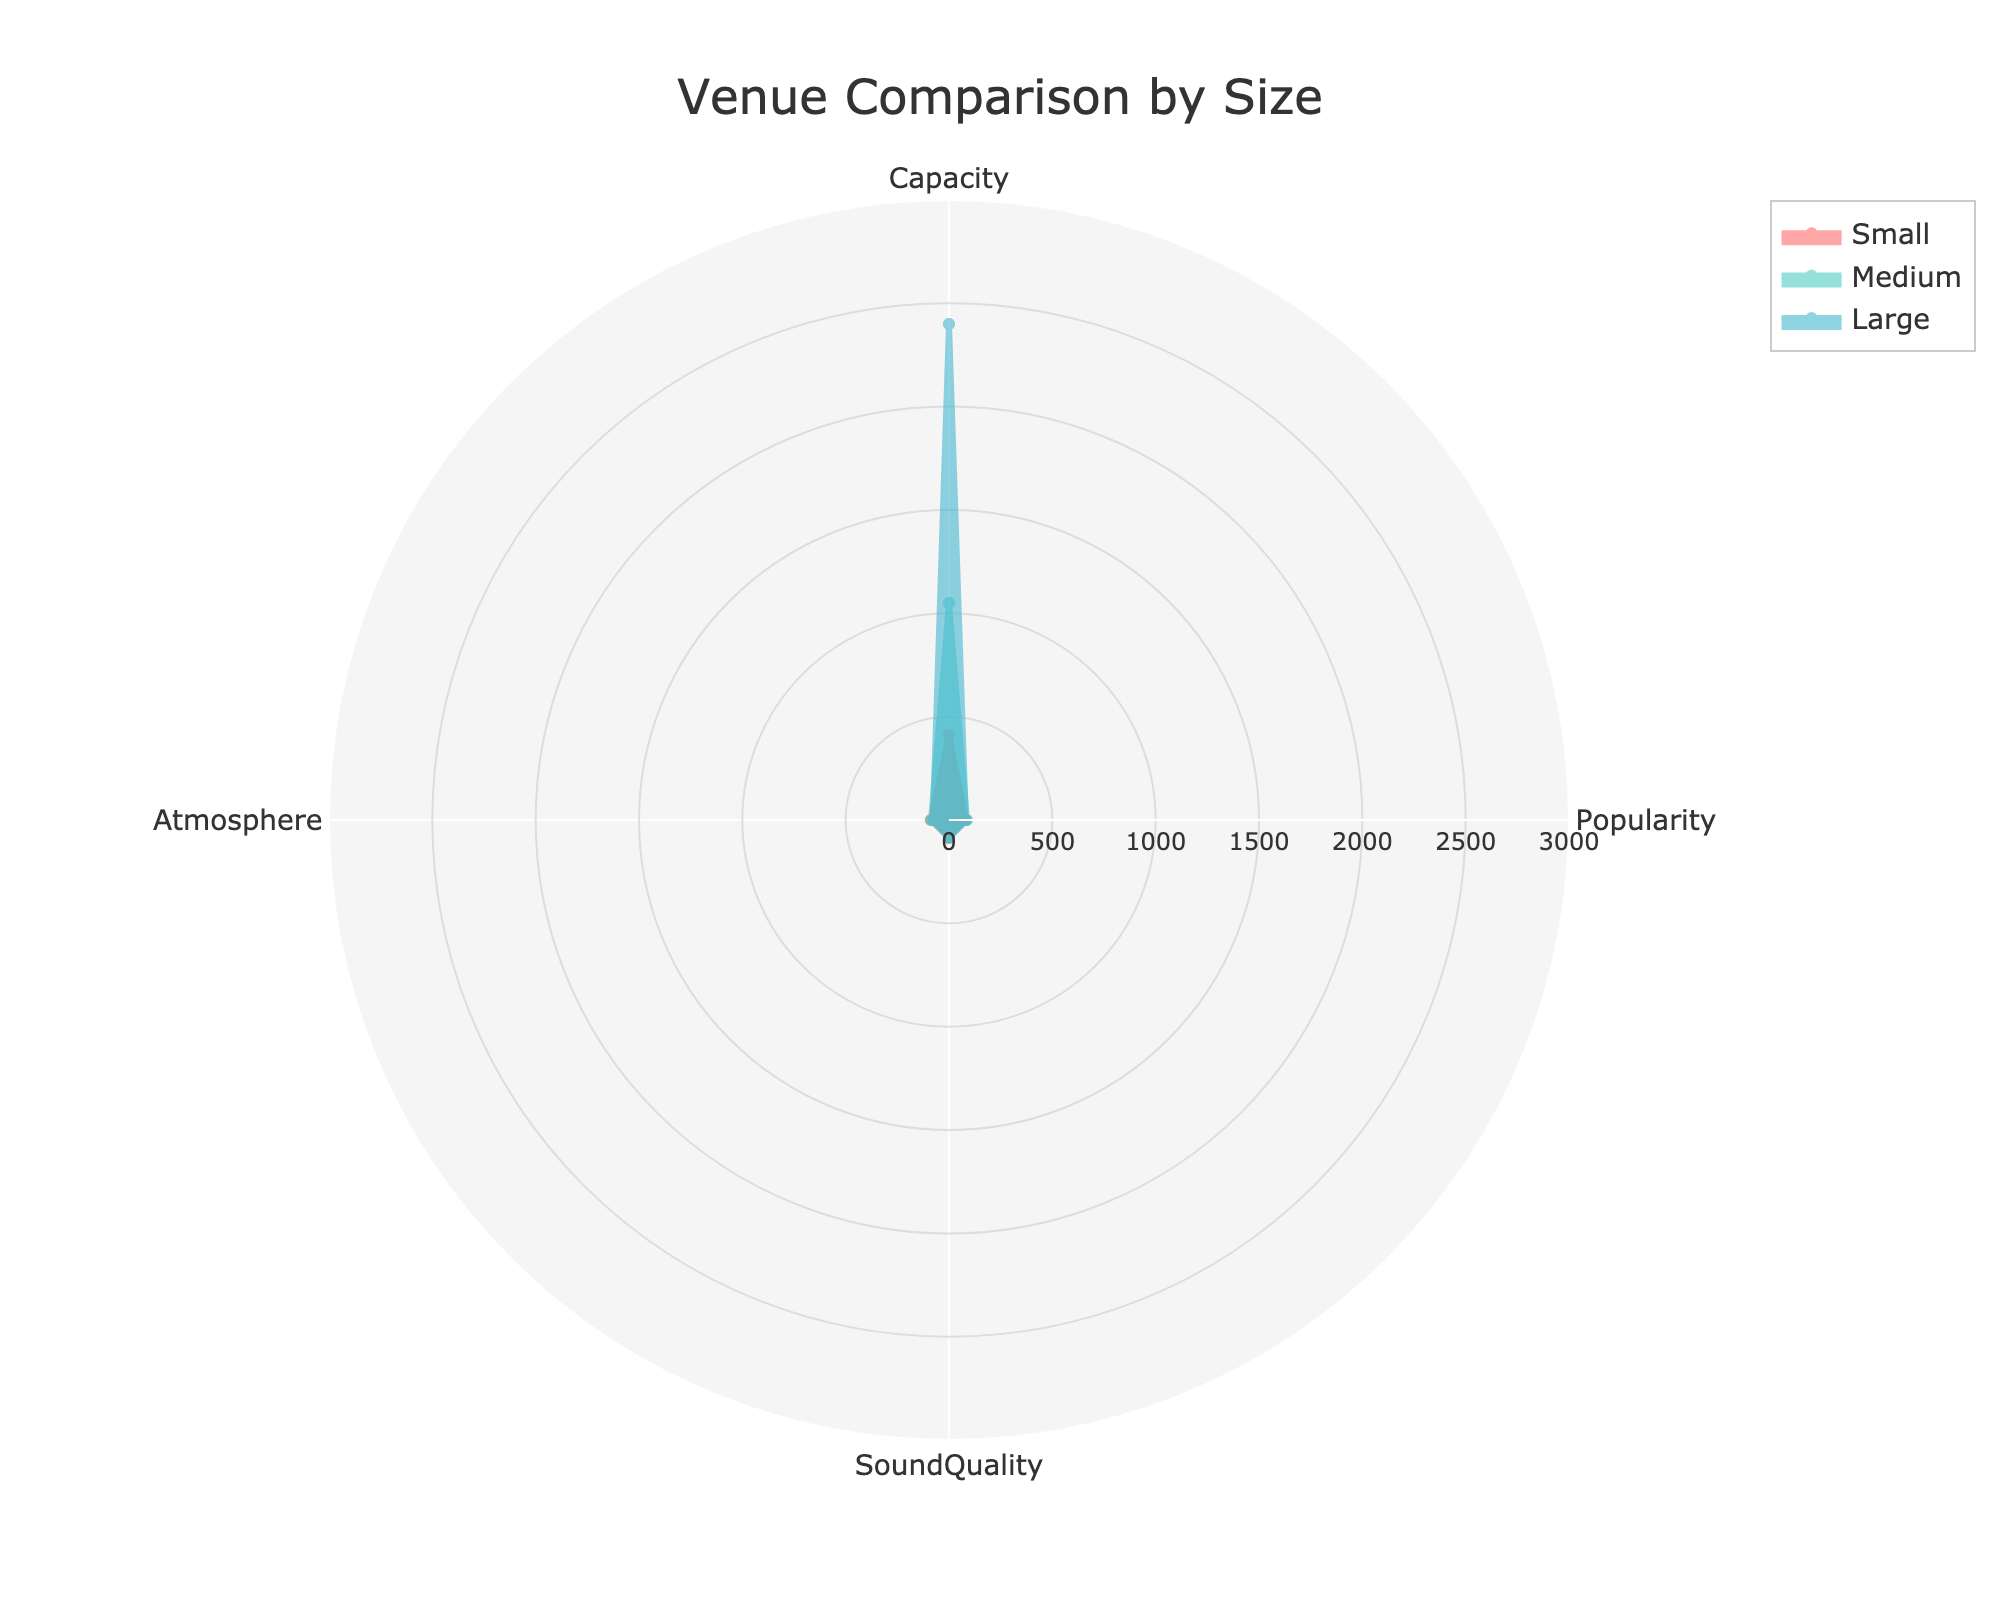How many categories are compared on the radar chart? The radar chart shows measurements across 4 distinct categories, which are used to compare the different venue sizes. These categories are noted at each axis of the chart.
Answer: 4 Which venue size has the highest average value for SoundQuality? To determine this, you locate the SoundQuality axis and observe where each size group (small, medium, large) extends. You see that the Medium size venues have the highest average value on the SoundQuality axis.
Answer: Medium How does the popularity of Large venues compare to Small venues? By examining the Popularity axis, you notice that the line and area representing Large venues are lower than that for Small venues. This indicates that the average popularity of Large venues is less than that of Small venues.
Answer: Large venues are less popular than Small venues What is the average capacity of Medium-sized venues displayed on the radar chart? The radar chart's capacity axis shows Medium venues, which include Music Hall of Williamsburg (650), Irving Plaza (1000), and Webster Hall (1500). The average capacity is calculated by adding these values and dividing by the number of venues: (650 + 1000 + 1500) / 3 = 3500 / 3.
Answer: 1167 Between Small and Medium venue sizes, which one has better Atmosphere ratings? By looking at the Atmosphere axis, you find that the line and area for the Medium venues extend further than that for Small venues. Thus, the Medium venues have better Atmosphere ratings.
Answer: Medium Which venue size category has the widest range in its Capacity values? To find the range, you look at the minimum and maximum values on the Capacity axis for each category. Medium venues have capacities ranging from 650 to 1500, while Large venues range from 1800 to 3000, and Small venues go from 250 to 575. Subtracting the smallest from the largest value gives you the ranges: 
Medium (1500 - 650 = 850), 
Large (3000 - 1800 = 1200), 
Small (575 - 250 = 325). 
Therefore, Large venues have the widest range.
Answer: Large Basically, what color represents Medium-sized venues? The color associated with each venue size is visibly distinct on the chart. The Medium-sized venues are represented in a greenish-blue hue.
Answer: Greenish-blue What's the difference in average Atmosphere ratings between Small and Large venue sizes? The radar chart shows the average Atmosphere ratings for Small and Large venue sizes. You find the Atmosphere axis for both, noting that Small venues have ratings of 78.5 and Large venues 78. The difference is calculated as 78.5 - 78.
Answer: 7 On which aspect do Small venues outperform Medium venues? To identify this, you examine each category axis, comparing the extent to which the Small venues surpass the Medium venues. According to the chart, Small venues exceed Medium venues in SoundQuality.
Answer: SoundQuality 